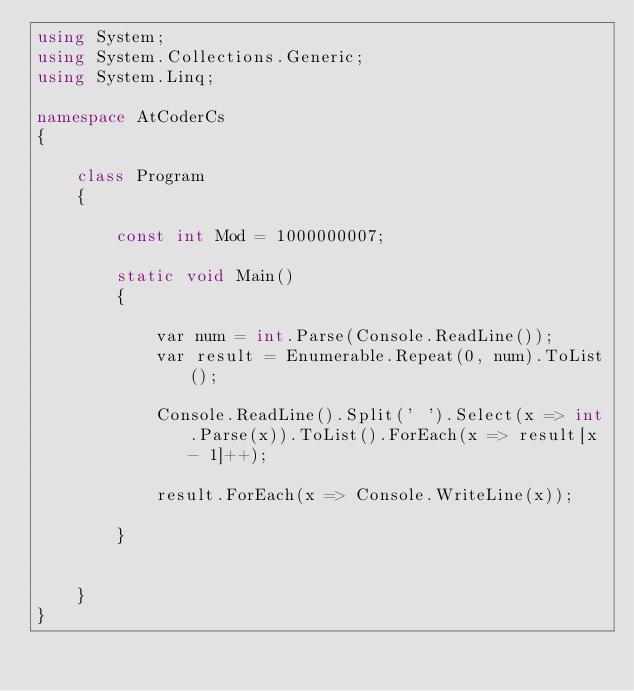<code> <loc_0><loc_0><loc_500><loc_500><_C#_>using System;
using System.Collections.Generic;
using System.Linq;

namespace AtCoderCs
{

    class Program
    {

        const int Mod = 1000000007;

        static void Main()
        {

            var num = int.Parse(Console.ReadLine());
            var result = Enumerable.Repeat(0, num).ToList();

            Console.ReadLine().Split(' ').Select(x => int.Parse(x)).ToList().ForEach(x => result[x - 1]++);

            result.ForEach(x => Console.WriteLine(x));
            
        }


    }
}
</code> 